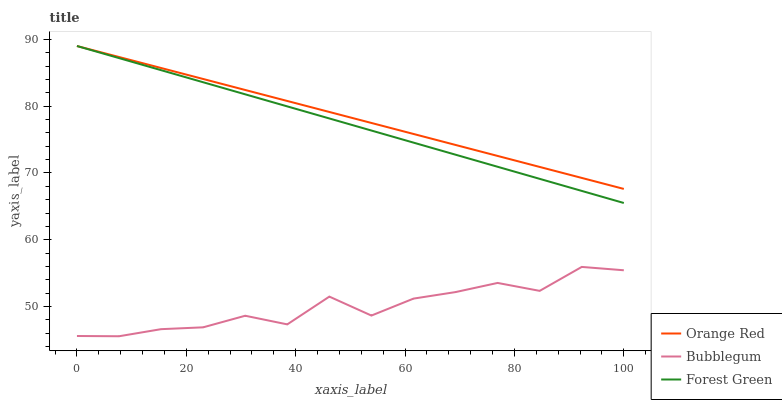Does Orange Red have the minimum area under the curve?
Answer yes or no. No. Does Bubblegum have the maximum area under the curve?
Answer yes or no. No. Is Orange Red the smoothest?
Answer yes or no. No. Is Orange Red the roughest?
Answer yes or no. No. Does Orange Red have the lowest value?
Answer yes or no. No. Does Bubblegum have the highest value?
Answer yes or no. No. Is Bubblegum less than Forest Green?
Answer yes or no. Yes. Is Forest Green greater than Bubblegum?
Answer yes or no. Yes. Does Bubblegum intersect Forest Green?
Answer yes or no. No. 